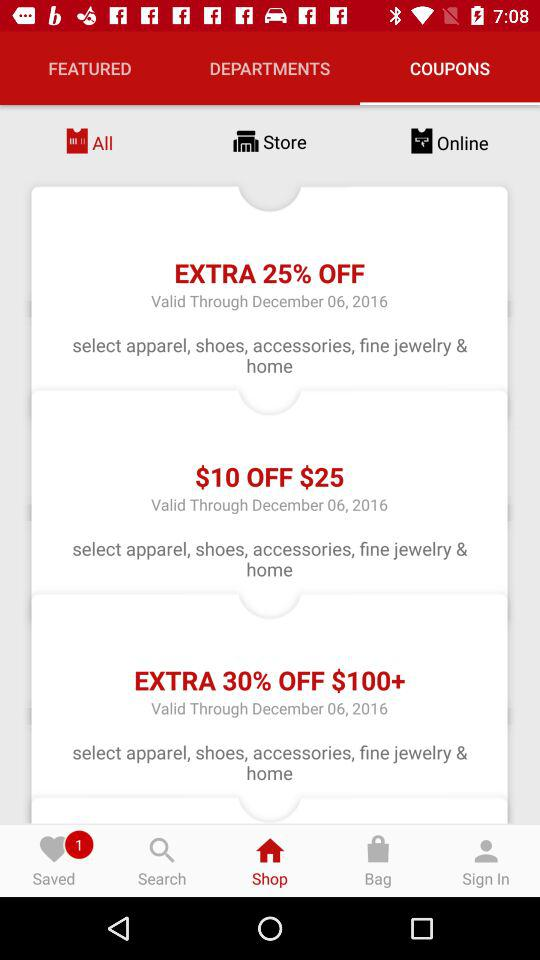How many coupons are there that are valid through December 06, 2016?
Answer the question using a single word or phrase. 3 